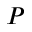<formula> <loc_0><loc_0><loc_500><loc_500>P</formula> 